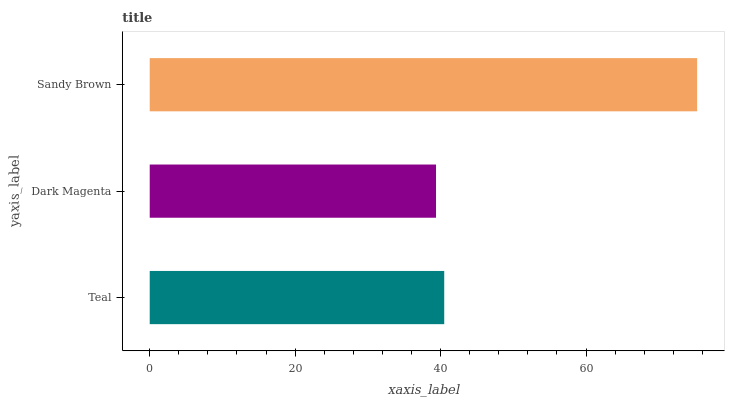Is Dark Magenta the minimum?
Answer yes or no. Yes. Is Sandy Brown the maximum?
Answer yes or no. Yes. Is Sandy Brown the minimum?
Answer yes or no. No. Is Dark Magenta the maximum?
Answer yes or no. No. Is Sandy Brown greater than Dark Magenta?
Answer yes or no. Yes. Is Dark Magenta less than Sandy Brown?
Answer yes or no. Yes. Is Dark Magenta greater than Sandy Brown?
Answer yes or no. No. Is Sandy Brown less than Dark Magenta?
Answer yes or no. No. Is Teal the high median?
Answer yes or no. Yes. Is Teal the low median?
Answer yes or no. Yes. Is Dark Magenta the high median?
Answer yes or no. No. Is Dark Magenta the low median?
Answer yes or no. No. 